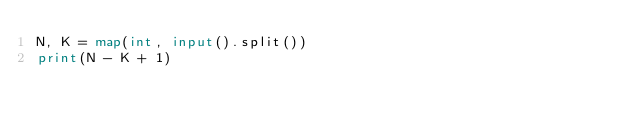Convert code to text. <code><loc_0><loc_0><loc_500><loc_500><_Python_>N, K = map(int, input().split())
print(N - K + 1)</code> 